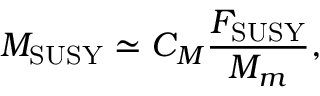Convert formula to latex. <formula><loc_0><loc_0><loc_500><loc_500>M _ { S U S Y } \simeq C _ { M } \frac { F _ { S U S Y } } { M _ { m } } ,</formula> 